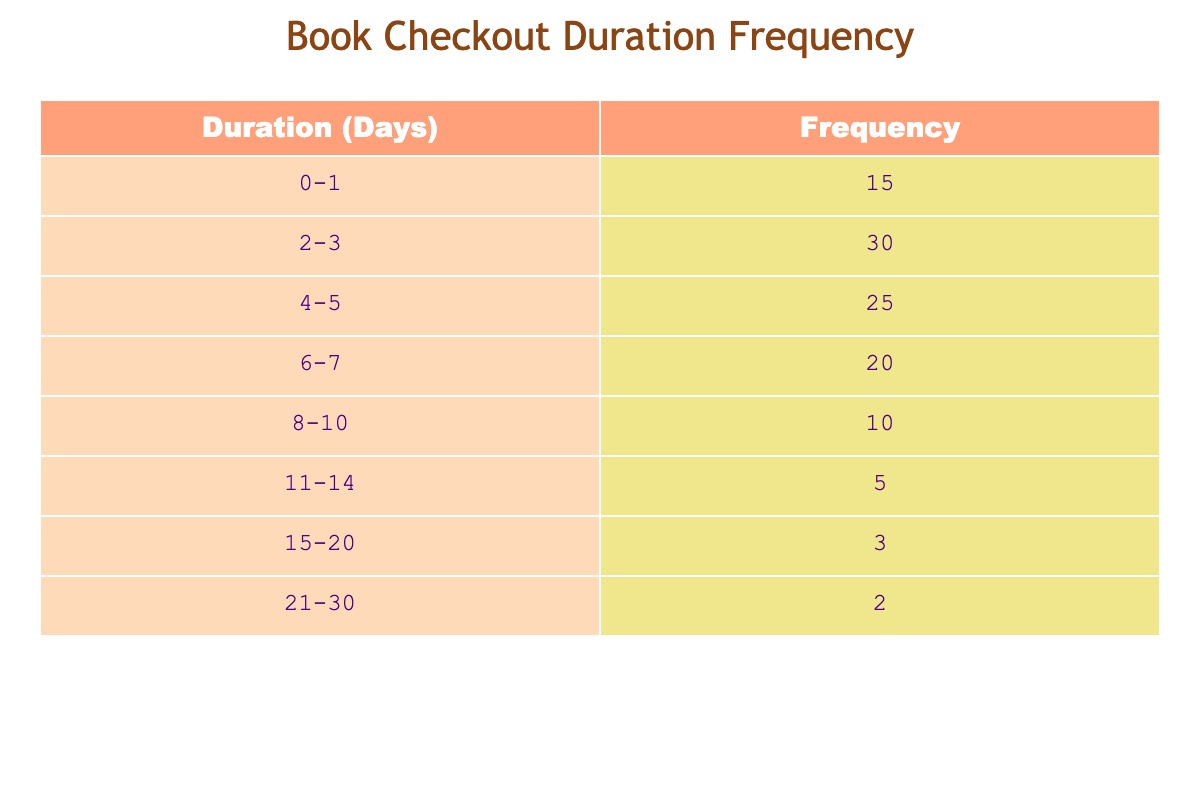What is the frequency of book checkouts for the duration of 0-1 days? The table directly shows that the frequency for the duration of 0-1 days is 15.
Answer: 15 What is the highest frequency of book checkout durations listed in the table? By looking through the frequency values, the highest value is 30, which corresponds to the duration of 2-3 days.
Answer: 30 How many total checkouts occurred for durations longer than 10 days? To find this, we sum frequencies for 11-14 (5), 15-20 (3), and 21-30 (2), yielding 5 + 3 + 2 = 10.
Answer: 10 How many checkouts were for durations of 8 days or more? To get this, we sum the frequencies for durations of 8-10 (10), 11-14 (5), 15-20 (3), and 21-30 (2), which gives 10 + 5 + 3 + 2 = 20.
Answer: 20 Is there a duration range with a frequency of 10 checkouts? Yes, there is a duration range of 8-10 days that has a frequency of 10 checkouts.
Answer: Yes What range of checkout durations has the lowest frequency? The lowest frequency is 2, which corresponds to the duration of 21-30 days.
Answer: 21-30 days What is the total frequency of book checkouts for all durations? The total frequency is found by summing all frequency values: 15 + 30 + 25 + 20 + 10 + 5 + 3 + 2 = 110.
Answer: 110 Which duration range has a frequency of less than 10? The ranges that fit this criterion are 15-20 (3) and 21-30 (2).
Answer: 15-20 and 21-30 What is the average frequency of checkouts for the specified durations? To find the average, we first sum the frequencies: 110, and then divide by the number of duration ranges (8): 110/8 = 13.75.
Answer: 13.75 